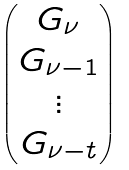<formula> <loc_0><loc_0><loc_500><loc_500>\begin{pmatrix} G _ { \nu } \\ G _ { \nu - 1 } \\ \vdots \\ G _ { \nu - t } \end{pmatrix}</formula> 